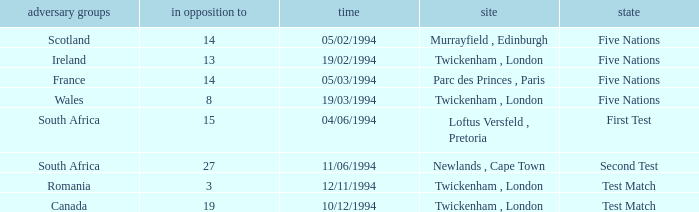How many against have a status of first test? 1.0. 